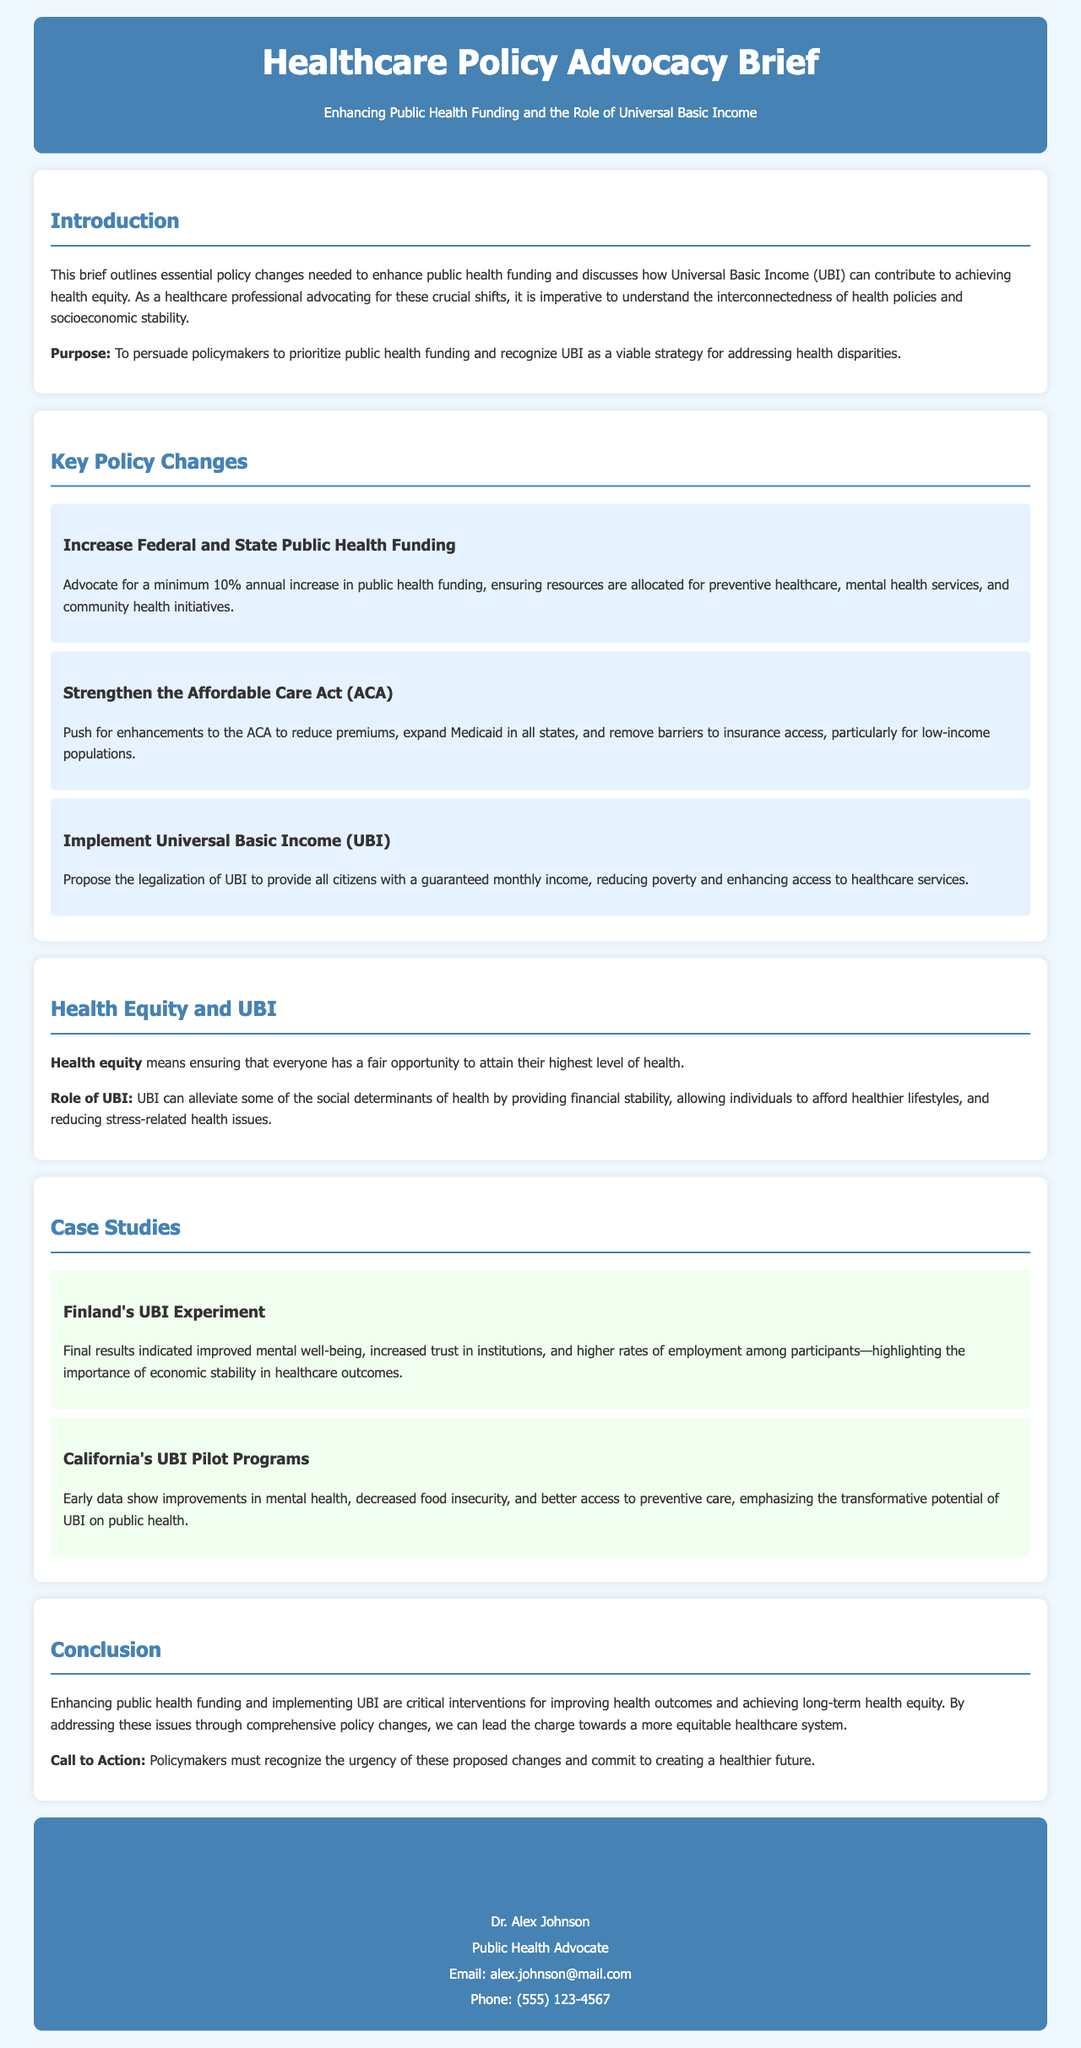What is the purpose of the brief? The purpose is to persuade policymakers to prioritize public health funding and recognize UBI as a viable strategy for addressing health disparities.
Answer: To persuade policymakers What annual increase in public health funding is being advocated? The document specifies advocating for a minimum 10% annual increase in public health funding.
Answer: 10% Who is the author of the document? The contact information section reveals the author as Dr. Alex Johnson.
Answer: Dr. Alex Johnson What is a defined term in the document for ensuring everyone has a fair opportunity to attain their highest level of health? The term described in the document is health equity.
Answer: Health equity Which country's UBI experiment is mentioned in the case studies? The case study references Finland's UBI Experiment.
Answer: Finland What key policy change relates to the ACA? The document mentions strengthening the Affordable Care Act (ACA) as a key policy change.
Answer: Strengthen the Affordable Care Act What is the role of UBI according to the document? The document states UBI can alleviate some of the social determinants of health by providing financial stability.
Answer: Financial stability What is the main call to action presented in the conclusion? The call to action emphasizes that policymakers must recognize the urgency of the proposed changes.
Answer: Recognize urgency What percentage of funding allocation is suggested for preventive healthcare according to the key policy changes? The documents suggest a focus on resources for preventive healthcare among others without stating a specific percentage.
Answer: Not specified 